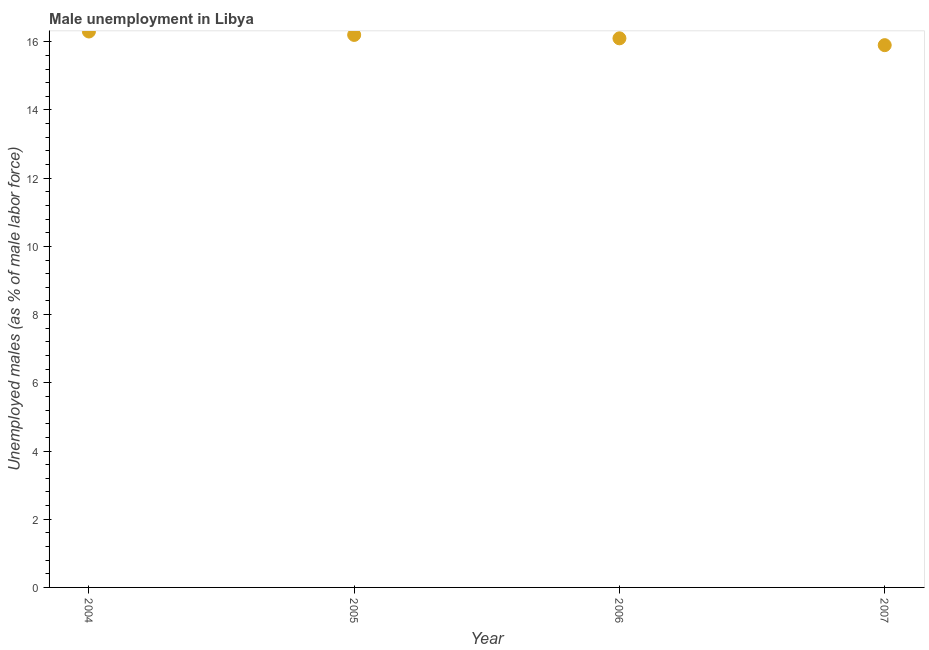What is the unemployed males population in 2004?
Make the answer very short. 16.3. Across all years, what is the maximum unemployed males population?
Offer a terse response. 16.3. Across all years, what is the minimum unemployed males population?
Provide a succinct answer. 15.9. What is the sum of the unemployed males population?
Your answer should be very brief. 64.5. What is the difference between the unemployed males population in 2005 and 2006?
Provide a succinct answer. 0.1. What is the average unemployed males population per year?
Make the answer very short. 16.12. What is the median unemployed males population?
Your answer should be very brief. 16.15. In how many years, is the unemployed males population greater than 12.8 %?
Your response must be concise. 4. What is the ratio of the unemployed males population in 2004 to that in 2007?
Offer a very short reply. 1.03. Is the difference between the unemployed males population in 2005 and 2007 greater than the difference between any two years?
Your response must be concise. No. What is the difference between the highest and the second highest unemployed males population?
Make the answer very short. 0.1. What is the difference between the highest and the lowest unemployed males population?
Offer a very short reply. 0.4. In how many years, is the unemployed males population greater than the average unemployed males population taken over all years?
Give a very brief answer. 2. Does the unemployed males population monotonically increase over the years?
Your answer should be very brief. No. How many years are there in the graph?
Provide a succinct answer. 4. What is the difference between two consecutive major ticks on the Y-axis?
Ensure brevity in your answer.  2. What is the title of the graph?
Offer a terse response. Male unemployment in Libya. What is the label or title of the Y-axis?
Make the answer very short. Unemployed males (as % of male labor force). What is the Unemployed males (as % of male labor force) in 2004?
Ensure brevity in your answer.  16.3. What is the Unemployed males (as % of male labor force) in 2005?
Provide a short and direct response. 16.2. What is the Unemployed males (as % of male labor force) in 2006?
Your response must be concise. 16.1. What is the Unemployed males (as % of male labor force) in 2007?
Give a very brief answer. 15.9. What is the difference between the Unemployed males (as % of male labor force) in 2004 and 2005?
Your answer should be compact. 0.1. What is the difference between the Unemployed males (as % of male labor force) in 2004 and 2007?
Your answer should be very brief. 0.4. What is the difference between the Unemployed males (as % of male labor force) in 2005 and 2006?
Your response must be concise. 0.1. What is the difference between the Unemployed males (as % of male labor force) in 2006 and 2007?
Offer a terse response. 0.2. What is the ratio of the Unemployed males (as % of male labor force) in 2004 to that in 2005?
Provide a short and direct response. 1.01. What is the ratio of the Unemployed males (as % of male labor force) in 2004 to that in 2007?
Your answer should be very brief. 1.02. What is the ratio of the Unemployed males (as % of male labor force) in 2005 to that in 2006?
Ensure brevity in your answer.  1.01. What is the ratio of the Unemployed males (as % of male labor force) in 2005 to that in 2007?
Make the answer very short. 1.02. 